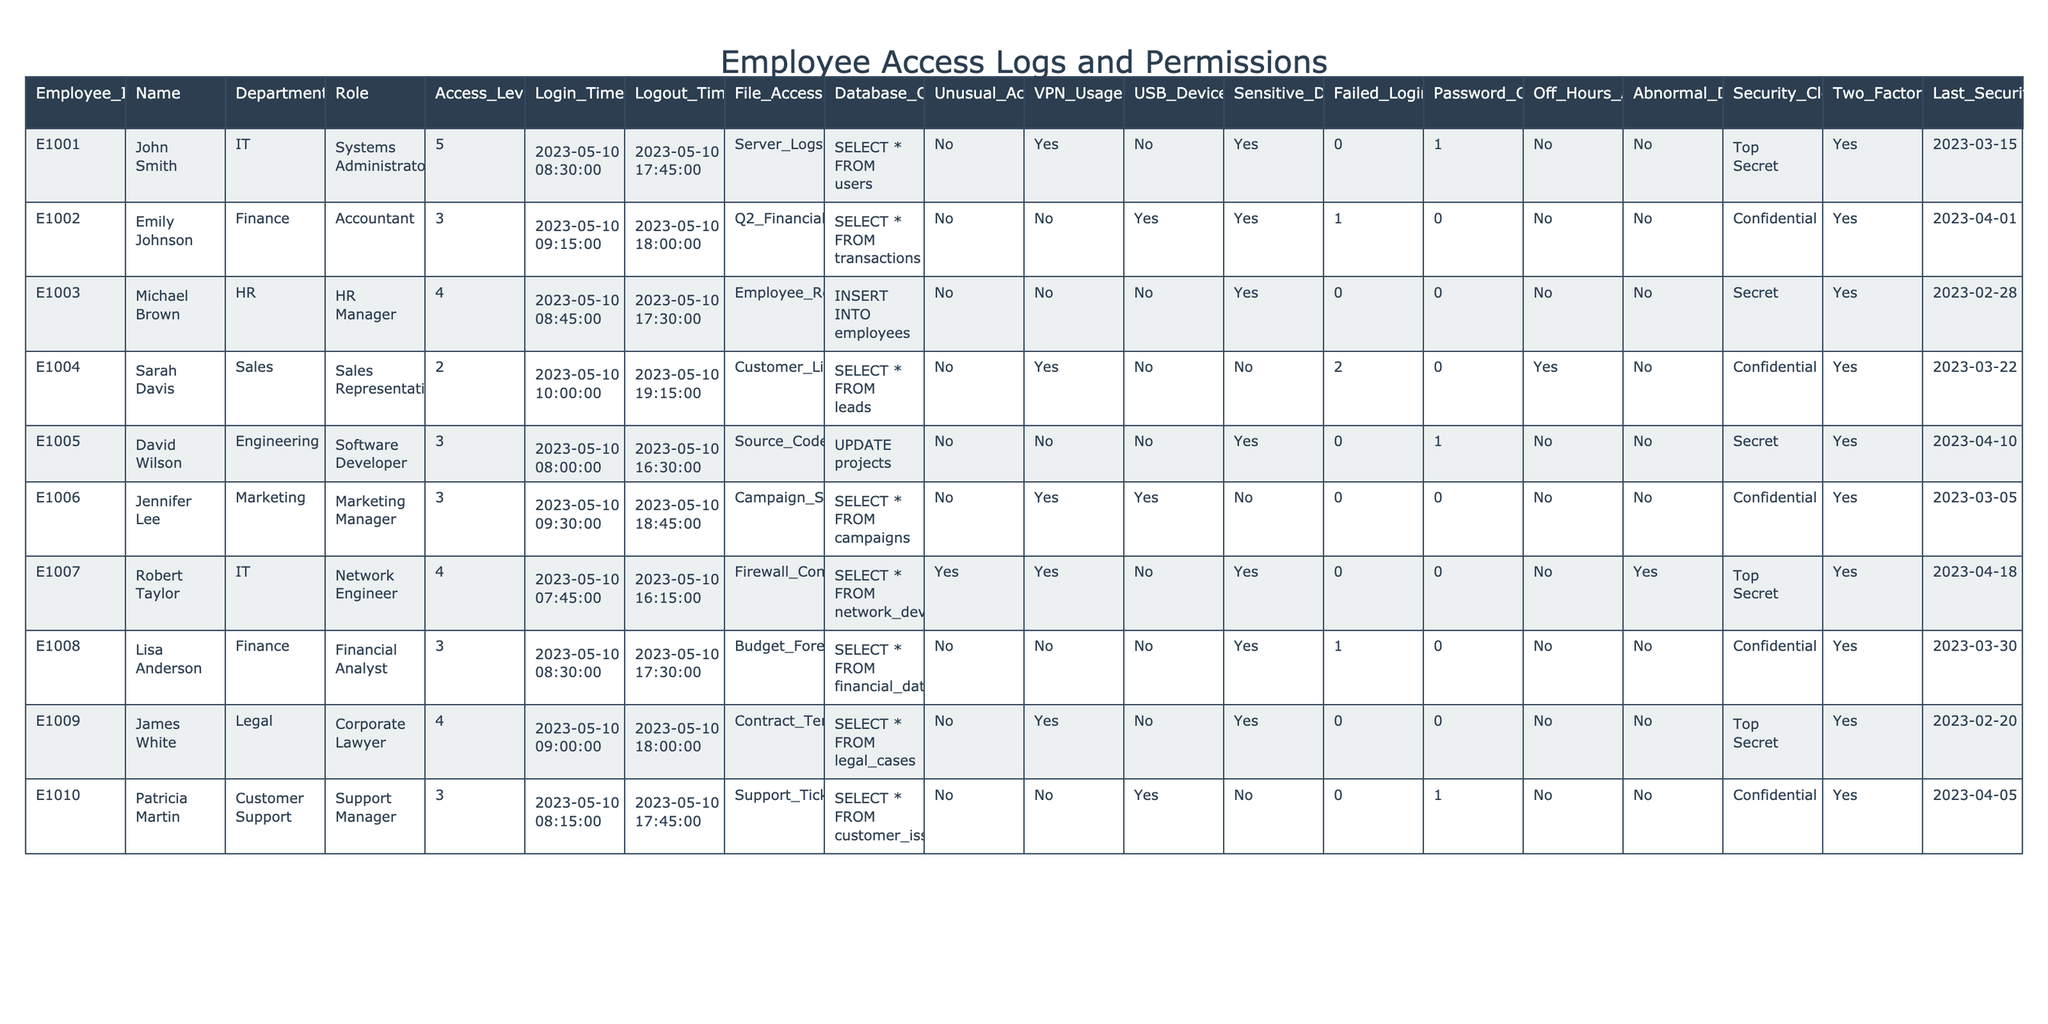What is the access level of John Smith? In the row corresponding to John Smith, the "Access_Level" column shows the value 5.
Answer: 5 How many employees accessed the VPN? By examining the "VPN_Usage" column, we see that Robert Taylor and John Smith used the VPN, totaling 2 employees.
Answer: 2 What is the department of the employee who accessed sensitive data the most? By reviewing the "Sensitive_Data_Accessed" column, only John Smith and Robert Taylor have accessed sensitive data, with both showing access, but the question asks for the department which is "IT" from John Smith or "IT" from Robert Taylor.
Answer: IT Did Sarah Davis have any failed login attempts? Checking the "Failed_Login_Attempts" column for Sarah Davis shows a value of 2, indicating she had failed login attempts.
Answer: Yes What role does Jennifer Lee hold? The "Role" column for Jennifer Lee's row specifies she is a "Marketing Manager."
Answer: Marketing Manager Who is the employee with the highest number of failed login attempts? Looking at the "Failed_Login_Attempts" column, Sarah Davis has the highest number with 2.
Answer: Sarah Davis What percentage of employees accessed sensitive data? Out of 10 employees, 3 accessed sensitive data. Hence, the percentage is (3/10)*100 = 30%.
Answer: 30% Is there any employee who has not completed security training in the last year? Upon inspecting the "Last_Security_Training" column, all employees have training dates earlier than the cutoff of the last year indicated by the current training date.
Answer: No Can you identify the employee who accessed files after hours? The "Off_Hours_Access" column shows that Sarah Davis accessed files after hours, indicating she is the only employee listed.
Answer: Sarah Davis What is the total number of employees with two-factor authentication enabled? By counting the "Two_Factor_Auth_Enabled" column, we find that 10 out of 10 employees have two-factor authentication, making the total count 10.
Answer: 10 Which department has the greatest number of employees accessing the databases? By checking the "Database_Query" column, it shows that employees from IT and Finance most frequently access the databases, with IT having 3 employees (including the Systems Administrator) accessing it.
Answer: IT How many employees have security clearance of "Top Secret"? Reviewing the "Security_Clearance" column, 3 employees (John Smith, Robert Taylor, James White) have "Top Secret" clearance.
Answer: 3 